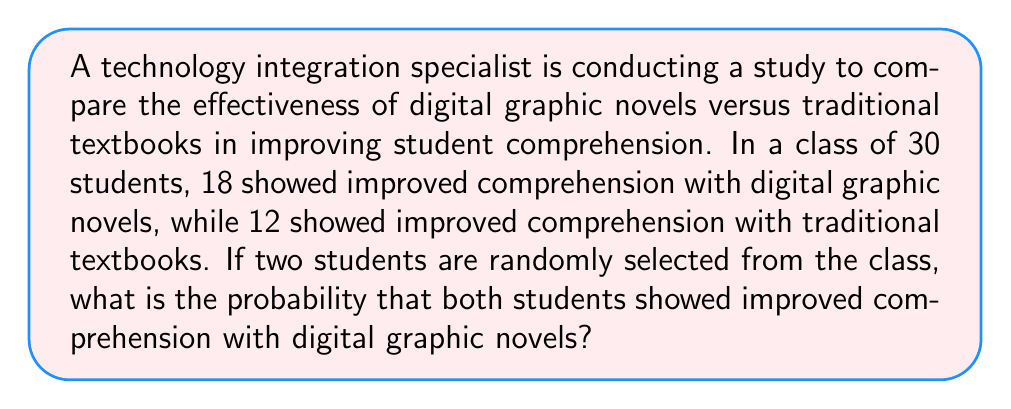Could you help me with this problem? To solve this problem, we need to use the concept of probability and combination.

1. First, let's calculate the probability of selecting one student who showed improved comprehension with digital graphic novels:
   $P(\text{digital}) = \frac{18}{30} = \frac{3}{5}$

2. Now, we need to calculate the probability of selecting two such students. This is a case of sampling without replacement, as the second selection depends on the outcome of the first.

3. For the first selection, we have 18 favorable outcomes out of 30 total outcomes.
   For the second selection, we have 17 favorable outcomes out of 29 total outcomes.

4. The probability of both events occurring is the product of their individual probabilities:

   $P(\text{both digital}) = \frac{18}{30} \cdot \frac{17}{29}$

5. Simplifying this expression:
   
   $P(\text{both digital}) = \frac{18 \cdot 17}{30 \cdot 29} = \frac{306}{870} = \frac{153}{435}$

6. To express this as a decimal, we divide 153 by 435:
   
   $\frac{153}{435} \approx 0.3517$

Therefore, the probability that both randomly selected students showed improved comprehension with digital graphic novels is approximately 0.3517 or about 35.17%.
Answer: $\frac{153}{435}$ or approximately 0.3517 (35.17%) 